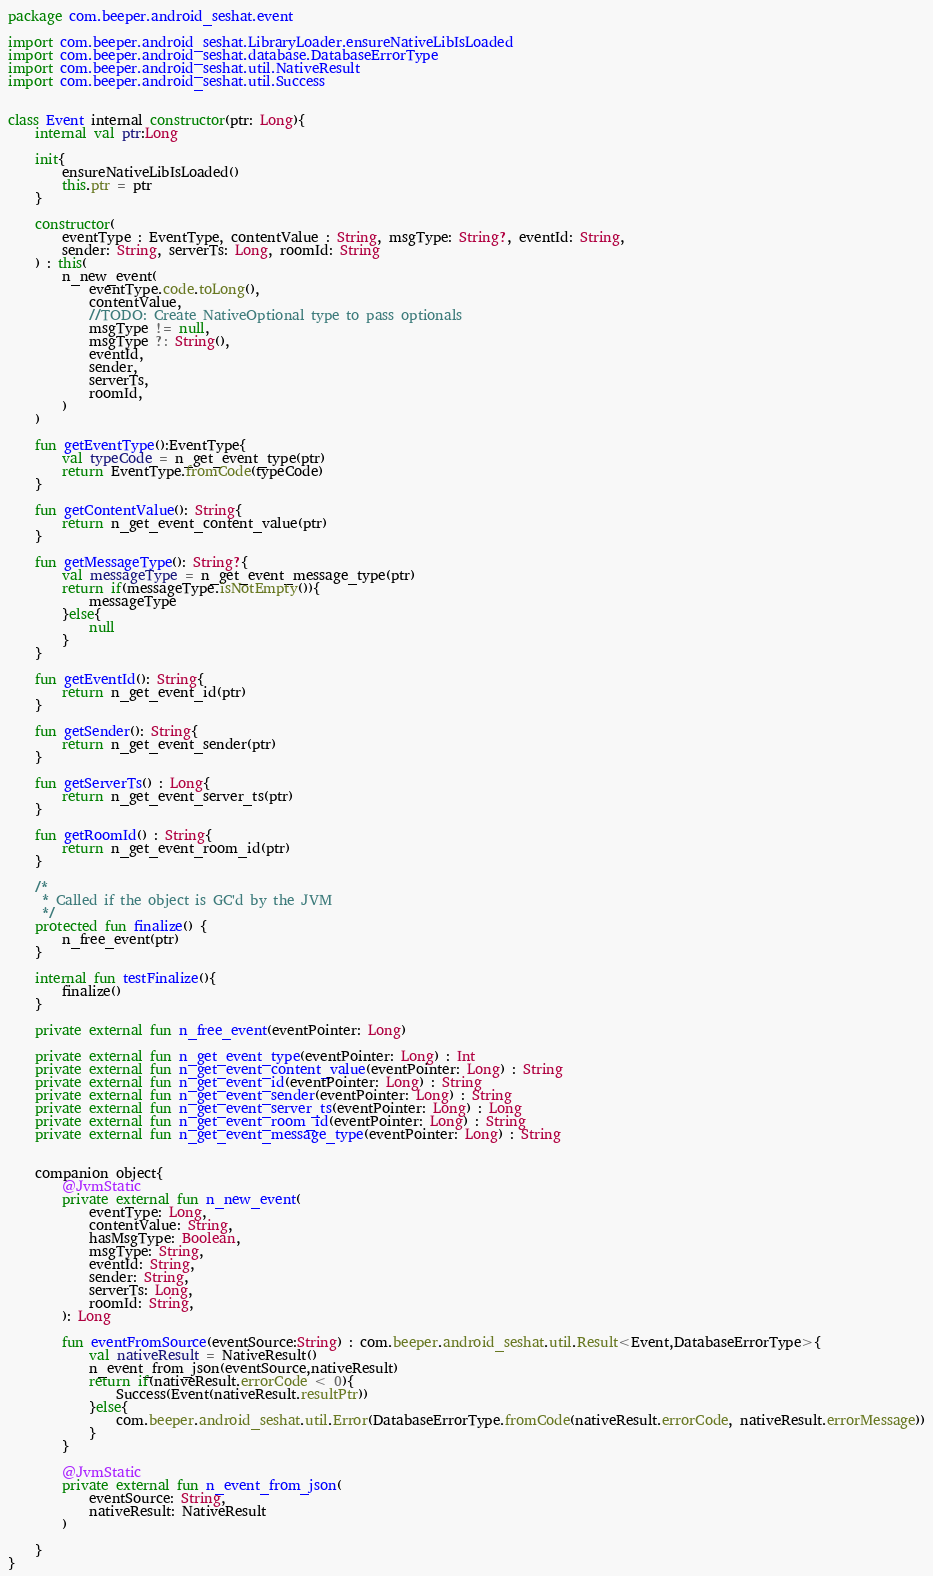<code> <loc_0><loc_0><loc_500><loc_500><_Kotlin_>package com.beeper.android_seshat.event

import com.beeper.android_seshat.LibraryLoader.ensureNativeLibIsLoaded
import com.beeper.android_seshat.database.DatabaseErrorType
import com.beeper.android_seshat.util.NativeResult
import com.beeper.android_seshat.util.Success


class Event internal constructor(ptr: Long){
    internal val ptr:Long

    init{
        ensureNativeLibIsLoaded()
        this.ptr = ptr
    }

    constructor(
        eventType : EventType, contentValue : String, msgType: String?, eventId: String,
        sender: String, serverTs: Long, roomId: String
    ) : this(
        n_new_event(
            eventType.code.toLong(),
            contentValue,
            //TODO: Create NativeOptional type to pass optionals
            msgType != null,
            msgType ?: String(),
            eventId,
            sender,
            serverTs,
            roomId,
        )
    )

    fun getEventType():EventType{
        val typeCode = n_get_event_type(ptr)
        return EventType.fromCode(typeCode)
    }

    fun getContentValue(): String{
        return n_get_event_content_value(ptr)
    }

    fun getMessageType(): String?{
        val messageType = n_get_event_message_type(ptr)
        return if(messageType.isNotEmpty()){
            messageType
        }else{
            null
        }
    }

    fun getEventId(): String{
        return n_get_event_id(ptr)
    }

    fun getSender(): String{
        return n_get_event_sender(ptr)
    }

    fun getServerTs() : Long{
        return n_get_event_server_ts(ptr)
    }

    fun getRoomId() : String{
        return n_get_event_room_id(ptr)
    }

    /*
     * Called if the object is GC'd by the JVM
     */
    protected fun finalize() {
        n_free_event(ptr)
    }

    internal fun testFinalize(){
        finalize()
    }

    private external fun n_free_event(eventPointer: Long)

    private external fun n_get_event_type(eventPointer: Long) : Int
    private external fun n_get_event_content_value(eventPointer: Long) : String
    private external fun n_get_event_id(eventPointer: Long) : String
    private external fun n_get_event_sender(eventPointer: Long) : String
    private external fun n_get_event_server_ts(eventPointer: Long) : Long
    private external fun n_get_event_room_id(eventPointer: Long) : String
    private external fun n_get_event_message_type(eventPointer: Long) : String


    companion object{
        @JvmStatic
        private external fun n_new_event(
            eventType: Long,
            contentValue: String,
            hasMsgType: Boolean,
            msgType: String,
            eventId: String,
            sender: String,
            serverTs: Long,
            roomId: String,
        ): Long

        fun eventFromSource(eventSource:String) : com.beeper.android_seshat.util.Result<Event,DatabaseErrorType>{
            val nativeResult = NativeResult()
            n_event_from_json(eventSource,nativeResult)
            return if(nativeResult.errorCode < 0){
                Success(Event(nativeResult.resultPtr))
            }else{
                com.beeper.android_seshat.util.Error(DatabaseErrorType.fromCode(nativeResult.errorCode, nativeResult.errorMessage))
            }
        }

        @JvmStatic
        private external fun n_event_from_json(
            eventSource: String,
            nativeResult: NativeResult
        )

    }
}
</code> 